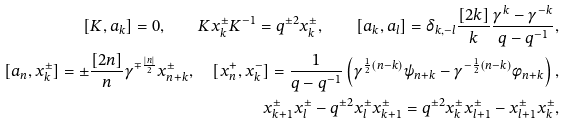Convert formula to latex. <formula><loc_0><loc_0><loc_500><loc_500>[ K , a _ { k } ] = 0 , \quad K x ^ { \pm } _ { k } K ^ { - 1 } = q ^ { \pm 2 } x ^ { \pm } _ { k } , \quad [ a _ { k } , a _ { l } ] = \delta _ { k , - l } \frac { [ 2 k ] } { k } \frac { \gamma ^ { k } - \gamma ^ { - k } } { q - q ^ { - 1 } } , \\ [ a _ { n } , x ^ { \pm } _ { k } ] = \pm \frac { [ 2 n ] } { n } \gamma ^ { \mp \frac { | n | } { 2 } } x ^ { \pm } _ { n + k } , \quad [ x ^ { + } _ { n } , x ^ { - } _ { k } ] = \frac { 1 } { q - q ^ { - 1 } } \left ( \gamma ^ { \frac { 1 } { 2 } ( n - k ) } \psi _ { n + k } - \gamma ^ { - \frac { 1 } { 2 } ( n - k ) } \phi _ { n + k } \right ) , \\ x ^ { \pm } _ { k + 1 } x ^ { \pm } _ { l } - q ^ { \pm 2 } x ^ { \pm } _ { l } x ^ { \pm } _ { k + 1 } = q ^ { \pm 2 } x ^ { \pm } _ { k } x ^ { \pm } _ { l + 1 } - x ^ { \pm } _ { l + 1 } x ^ { \pm } _ { k } ,</formula> 